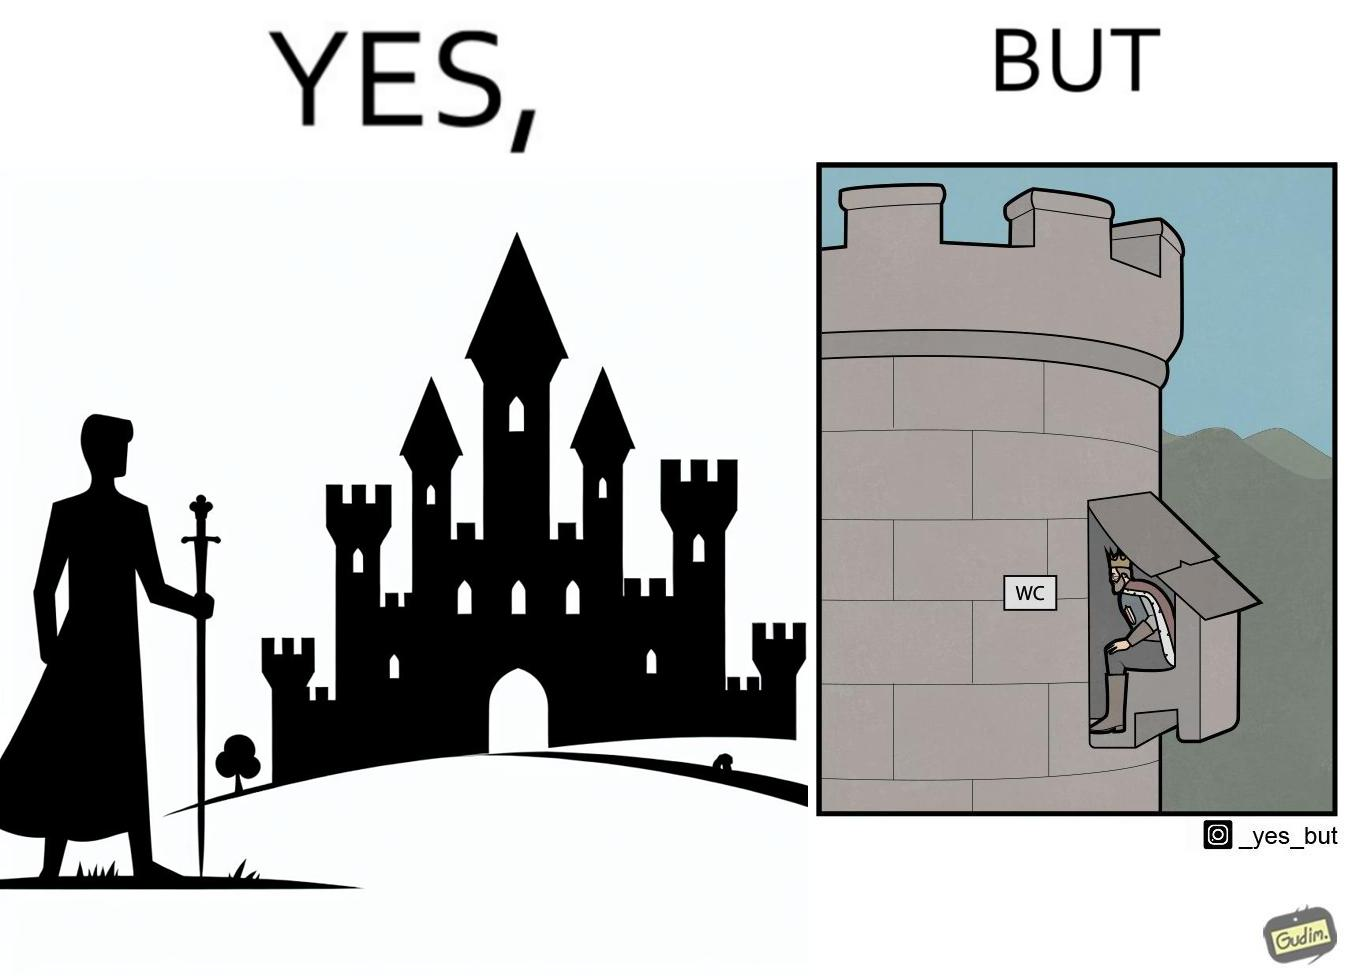What does this image depict? The images are funny since it shows how even a mighty king must do simple things like using a toilet just like everyone else does 